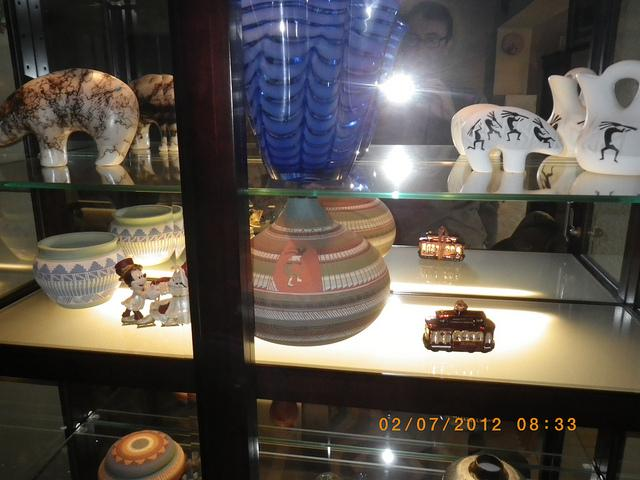What is the mouse's wife's name?

Choices:
A) justina
B) minnie
C) dasha
D) delores minnie 